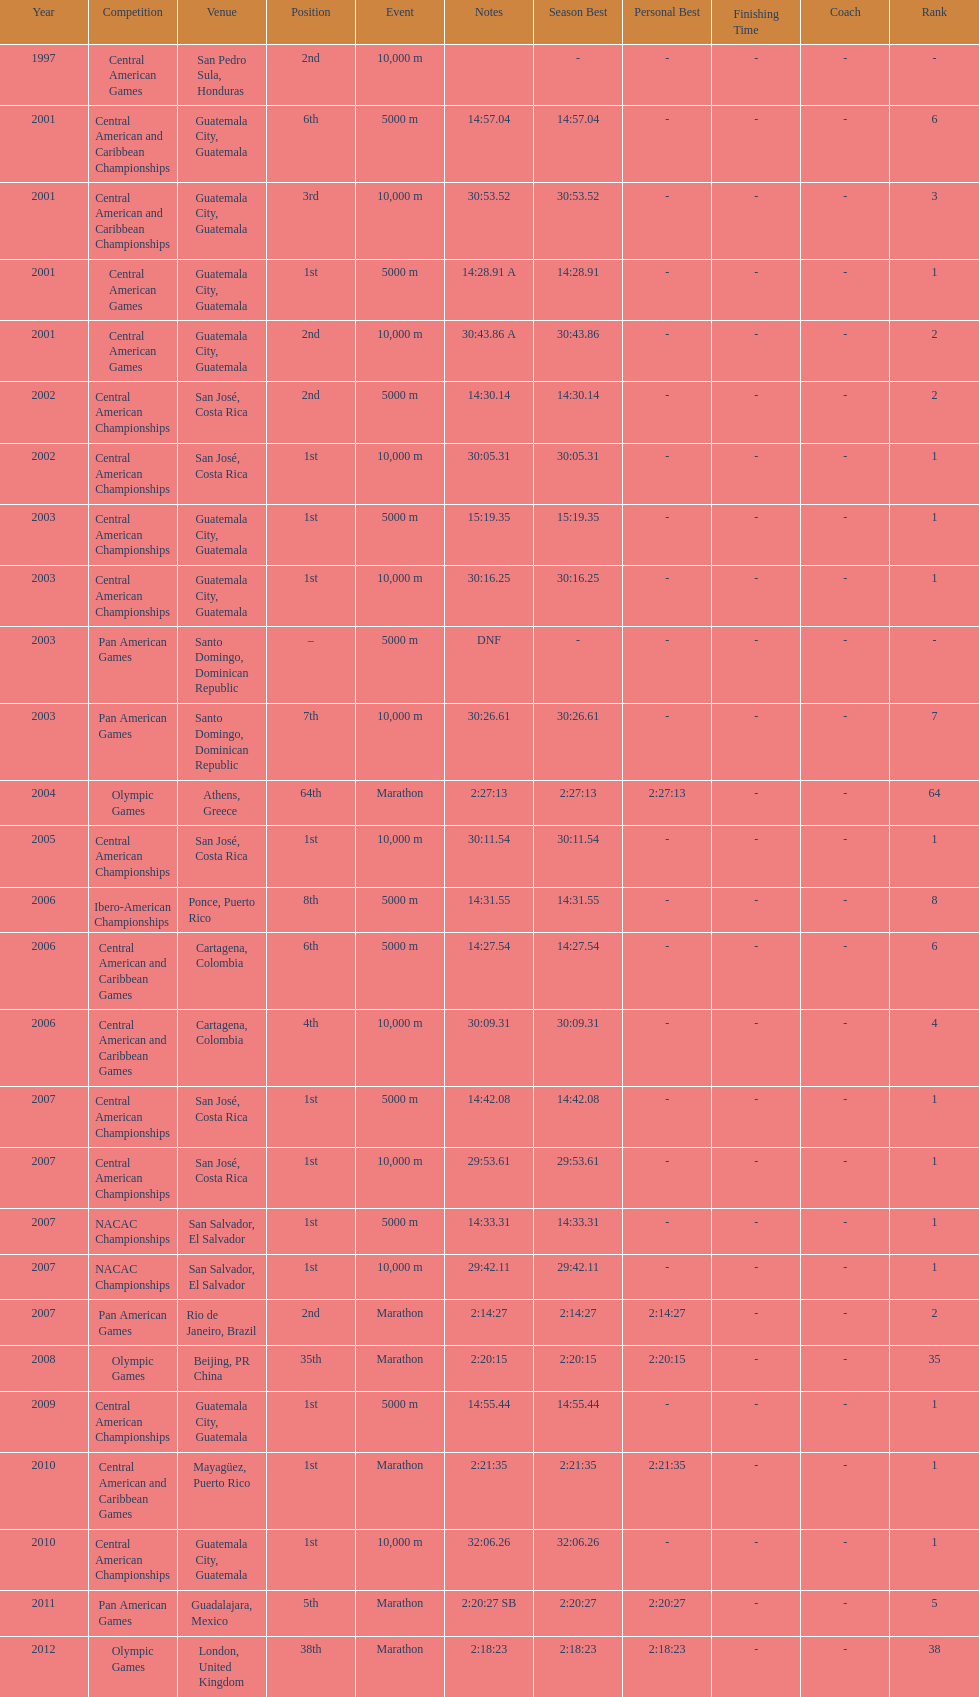What was the last competition in which a position of "2nd" was achieved? Pan American Games. 